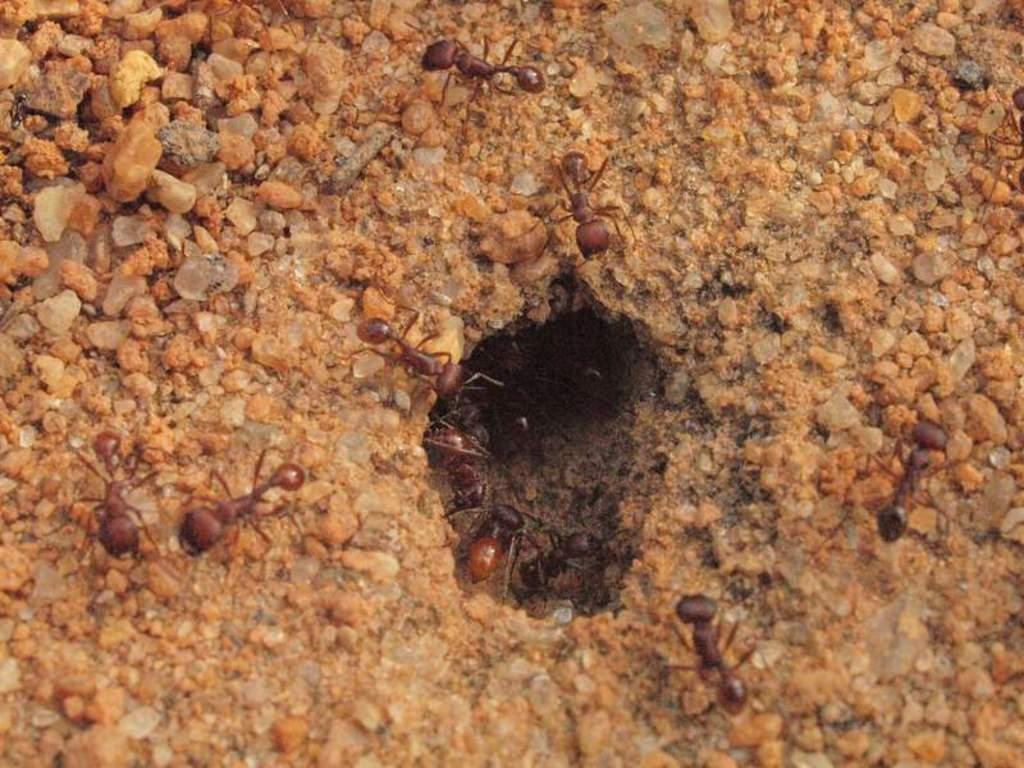How would you summarize this image in a sentence or two? This is the picture of a ground. In this image there are ants and stones and there's a hole. 